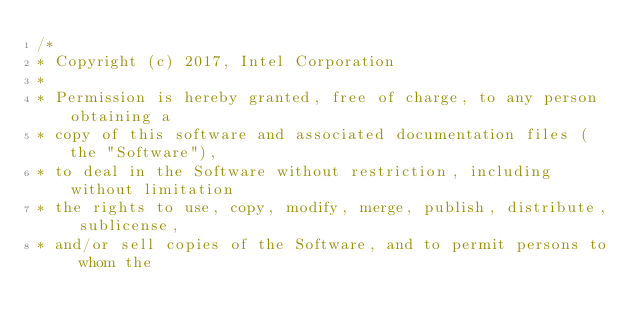<code> <loc_0><loc_0><loc_500><loc_500><_C++_>/*
* Copyright (c) 2017, Intel Corporation
*
* Permission is hereby granted, free of charge, to any person obtaining a
* copy of this software and associated documentation files (the "Software"),
* to deal in the Software without restriction, including without limitation
* the rights to use, copy, modify, merge, publish, distribute, sublicense,
* and/or sell copies of the Software, and to permit persons to whom the</code> 